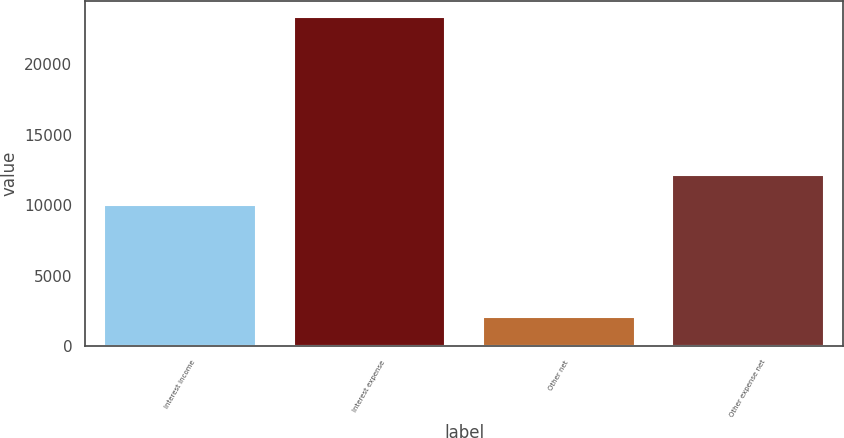Convert chart. <chart><loc_0><loc_0><loc_500><loc_500><bar_chart><fcel>Interest income<fcel>Interest expense<fcel>Other net<fcel>Other expense net<nl><fcel>9979<fcel>23370<fcel>2026<fcel>12113.4<nl></chart> 